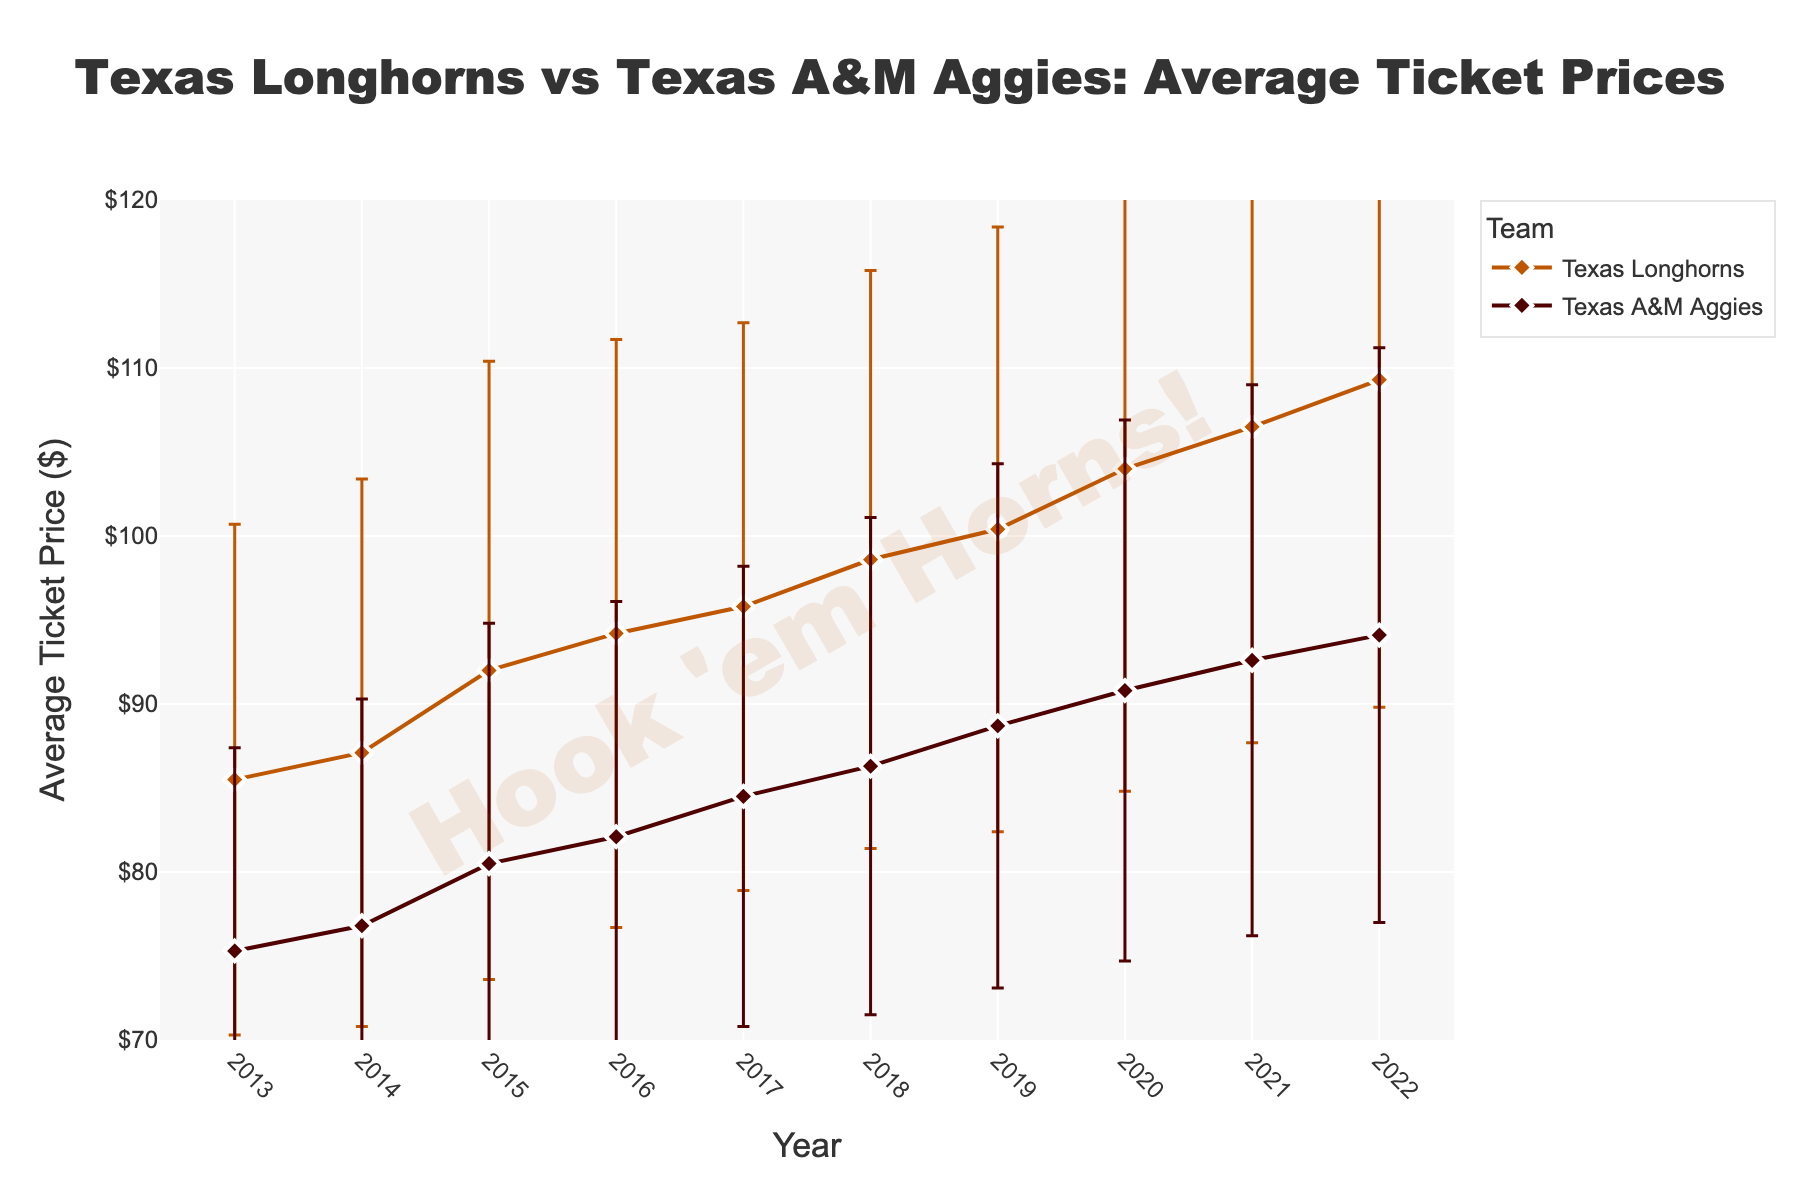What's the title of the figure? The title is displayed prominently at the top of the figure and describes its content. It usually summarizes the main point of the visualization.
Answer: Texas Longhorns vs Texas A&M Aggies: Average Ticket Prices What are the teams being compared in the figure? The teams are indicated in the legend of the figure, and their names are used in the title and annotated throughout the plot.
Answer: Texas Longhorns and Texas A&M Aggies Between which years does the data span? The x-axis of the figure represents the years, and it indicates the range of years for which data is available.
Answer: 2013 to 2022 Which team has higher average ticket prices in general? By observing the mean price lines of both teams over the years, you can determine which line generally lies above the other.
Answer: Texas Longhorns What is the average ticket price for the Texas Longhorns in 2020? You can find the year 2020 on the x-axis and then refer to the Texas Longhorns line to find the corresponding y-value.
Answer: $104.00 How does the price variability for Texas A&M Aggies change from 2013 to 2022? To answer this, observe the length of the error bars (representing standard deviation) for the Texas A&M Aggies from 2013 through 2022. Note if error bars are getting longer or shorter.
Answer: It increases slightly over time What is the difference in average ticket prices between the two teams in 2019? Find the mean prices for both teams in 2019 and subtract the Texas A&M Aggies’ price from the Texas Longhorns’ price.
Answer: $11.70 Which year had the highest average ticket price for the Texas Longhorns? Identify the peak point on the Texas Longhorns' line and note the corresponding year on the x-axis.
Answer: 2022 In which year were the average ticket prices closest for the two teams? Compare the prices of both teams year by year and find the year where the difference is minimal.
Answer: 2013 How consistent are the Texas Longhorns' ticket prices over the years? Consistency can be assessed by examining the error bars. Shorter error bars indicate higher consistency. Observe the error bars for Texas Longhorns from 2013 to 2022.
Answer: Moderately consistent 